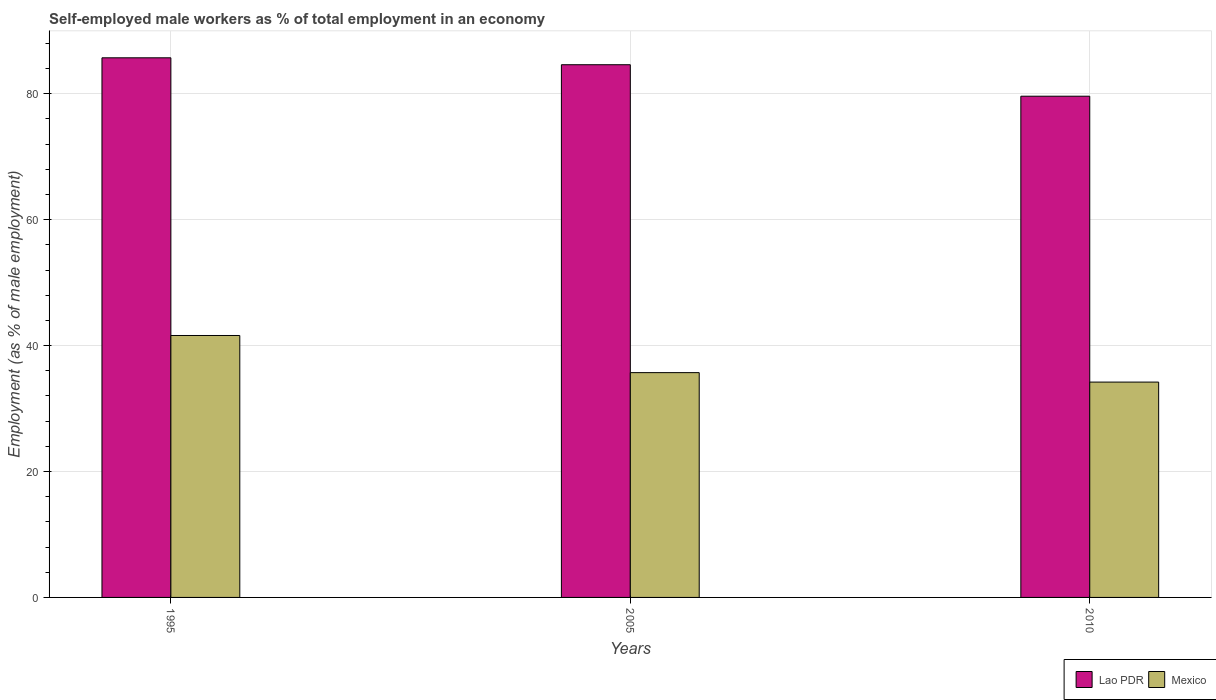Are the number of bars per tick equal to the number of legend labels?
Give a very brief answer. Yes. Are the number of bars on each tick of the X-axis equal?
Keep it short and to the point. Yes. What is the label of the 2nd group of bars from the left?
Offer a very short reply. 2005. What is the percentage of self-employed male workers in Mexico in 1995?
Provide a short and direct response. 41.6. Across all years, what is the maximum percentage of self-employed male workers in Mexico?
Offer a terse response. 41.6. Across all years, what is the minimum percentage of self-employed male workers in Mexico?
Provide a succinct answer. 34.2. In which year was the percentage of self-employed male workers in Lao PDR minimum?
Offer a very short reply. 2010. What is the total percentage of self-employed male workers in Mexico in the graph?
Provide a short and direct response. 111.5. What is the difference between the percentage of self-employed male workers in Lao PDR in 1995 and that in 2005?
Offer a very short reply. 1.1. What is the difference between the percentage of self-employed male workers in Lao PDR in 2005 and the percentage of self-employed male workers in Mexico in 1995?
Provide a succinct answer. 43. What is the average percentage of self-employed male workers in Mexico per year?
Keep it short and to the point. 37.17. In the year 2010, what is the difference between the percentage of self-employed male workers in Lao PDR and percentage of self-employed male workers in Mexico?
Keep it short and to the point. 45.4. In how many years, is the percentage of self-employed male workers in Mexico greater than 8 %?
Give a very brief answer. 3. What is the ratio of the percentage of self-employed male workers in Mexico in 1995 to that in 2010?
Your response must be concise. 1.22. Is the percentage of self-employed male workers in Lao PDR in 1995 less than that in 2010?
Give a very brief answer. No. Is the difference between the percentage of self-employed male workers in Lao PDR in 1995 and 2010 greater than the difference between the percentage of self-employed male workers in Mexico in 1995 and 2010?
Offer a very short reply. No. What is the difference between the highest and the second highest percentage of self-employed male workers in Mexico?
Provide a succinct answer. 5.9. What is the difference between the highest and the lowest percentage of self-employed male workers in Mexico?
Keep it short and to the point. 7.4. What does the 2nd bar from the left in 2010 represents?
Provide a succinct answer. Mexico. What does the 2nd bar from the right in 2010 represents?
Provide a succinct answer. Lao PDR. How many bars are there?
Give a very brief answer. 6. Are all the bars in the graph horizontal?
Your response must be concise. No. Where does the legend appear in the graph?
Provide a short and direct response. Bottom right. How many legend labels are there?
Ensure brevity in your answer.  2. What is the title of the graph?
Give a very brief answer. Self-employed male workers as % of total employment in an economy. Does "New Zealand" appear as one of the legend labels in the graph?
Your response must be concise. No. What is the label or title of the X-axis?
Your answer should be compact. Years. What is the label or title of the Y-axis?
Provide a short and direct response. Employment (as % of male employment). What is the Employment (as % of male employment) of Lao PDR in 1995?
Give a very brief answer. 85.7. What is the Employment (as % of male employment) of Mexico in 1995?
Your response must be concise. 41.6. What is the Employment (as % of male employment) of Lao PDR in 2005?
Provide a succinct answer. 84.6. What is the Employment (as % of male employment) in Mexico in 2005?
Ensure brevity in your answer.  35.7. What is the Employment (as % of male employment) of Lao PDR in 2010?
Ensure brevity in your answer.  79.6. What is the Employment (as % of male employment) in Mexico in 2010?
Keep it short and to the point. 34.2. Across all years, what is the maximum Employment (as % of male employment) in Lao PDR?
Provide a short and direct response. 85.7. Across all years, what is the maximum Employment (as % of male employment) in Mexico?
Your answer should be compact. 41.6. Across all years, what is the minimum Employment (as % of male employment) of Lao PDR?
Keep it short and to the point. 79.6. Across all years, what is the minimum Employment (as % of male employment) of Mexico?
Provide a succinct answer. 34.2. What is the total Employment (as % of male employment) in Lao PDR in the graph?
Provide a succinct answer. 249.9. What is the total Employment (as % of male employment) of Mexico in the graph?
Offer a very short reply. 111.5. What is the difference between the Employment (as % of male employment) of Mexico in 1995 and that in 2005?
Your response must be concise. 5.9. What is the difference between the Employment (as % of male employment) of Lao PDR in 1995 and that in 2010?
Your answer should be compact. 6.1. What is the difference between the Employment (as % of male employment) of Lao PDR in 2005 and that in 2010?
Keep it short and to the point. 5. What is the difference between the Employment (as % of male employment) of Lao PDR in 1995 and the Employment (as % of male employment) of Mexico in 2010?
Provide a succinct answer. 51.5. What is the difference between the Employment (as % of male employment) of Lao PDR in 2005 and the Employment (as % of male employment) of Mexico in 2010?
Your answer should be very brief. 50.4. What is the average Employment (as % of male employment) of Lao PDR per year?
Offer a very short reply. 83.3. What is the average Employment (as % of male employment) of Mexico per year?
Offer a very short reply. 37.17. In the year 1995, what is the difference between the Employment (as % of male employment) of Lao PDR and Employment (as % of male employment) of Mexico?
Your answer should be very brief. 44.1. In the year 2005, what is the difference between the Employment (as % of male employment) in Lao PDR and Employment (as % of male employment) in Mexico?
Ensure brevity in your answer.  48.9. In the year 2010, what is the difference between the Employment (as % of male employment) of Lao PDR and Employment (as % of male employment) of Mexico?
Provide a succinct answer. 45.4. What is the ratio of the Employment (as % of male employment) of Mexico in 1995 to that in 2005?
Make the answer very short. 1.17. What is the ratio of the Employment (as % of male employment) in Lao PDR in 1995 to that in 2010?
Make the answer very short. 1.08. What is the ratio of the Employment (as % of male employment) of Mexico in 1995 to that in 2010?
Ensure brevity in your answer.  1.22. What is the ratio of the Employment (as % of male employment) of Lao PDR in 2005 to that in 2010?
Provide a short and direct response. 1.06. What is the ratio of the Employment (as % of male employment) in Mexico in 2005 to that in 2010?
Offer a very short reply. 1.04. What is the difference between the highest and the second highest Employment (as % of male employment) of Lao PDR?
Give a very brief answer. 1.1. 